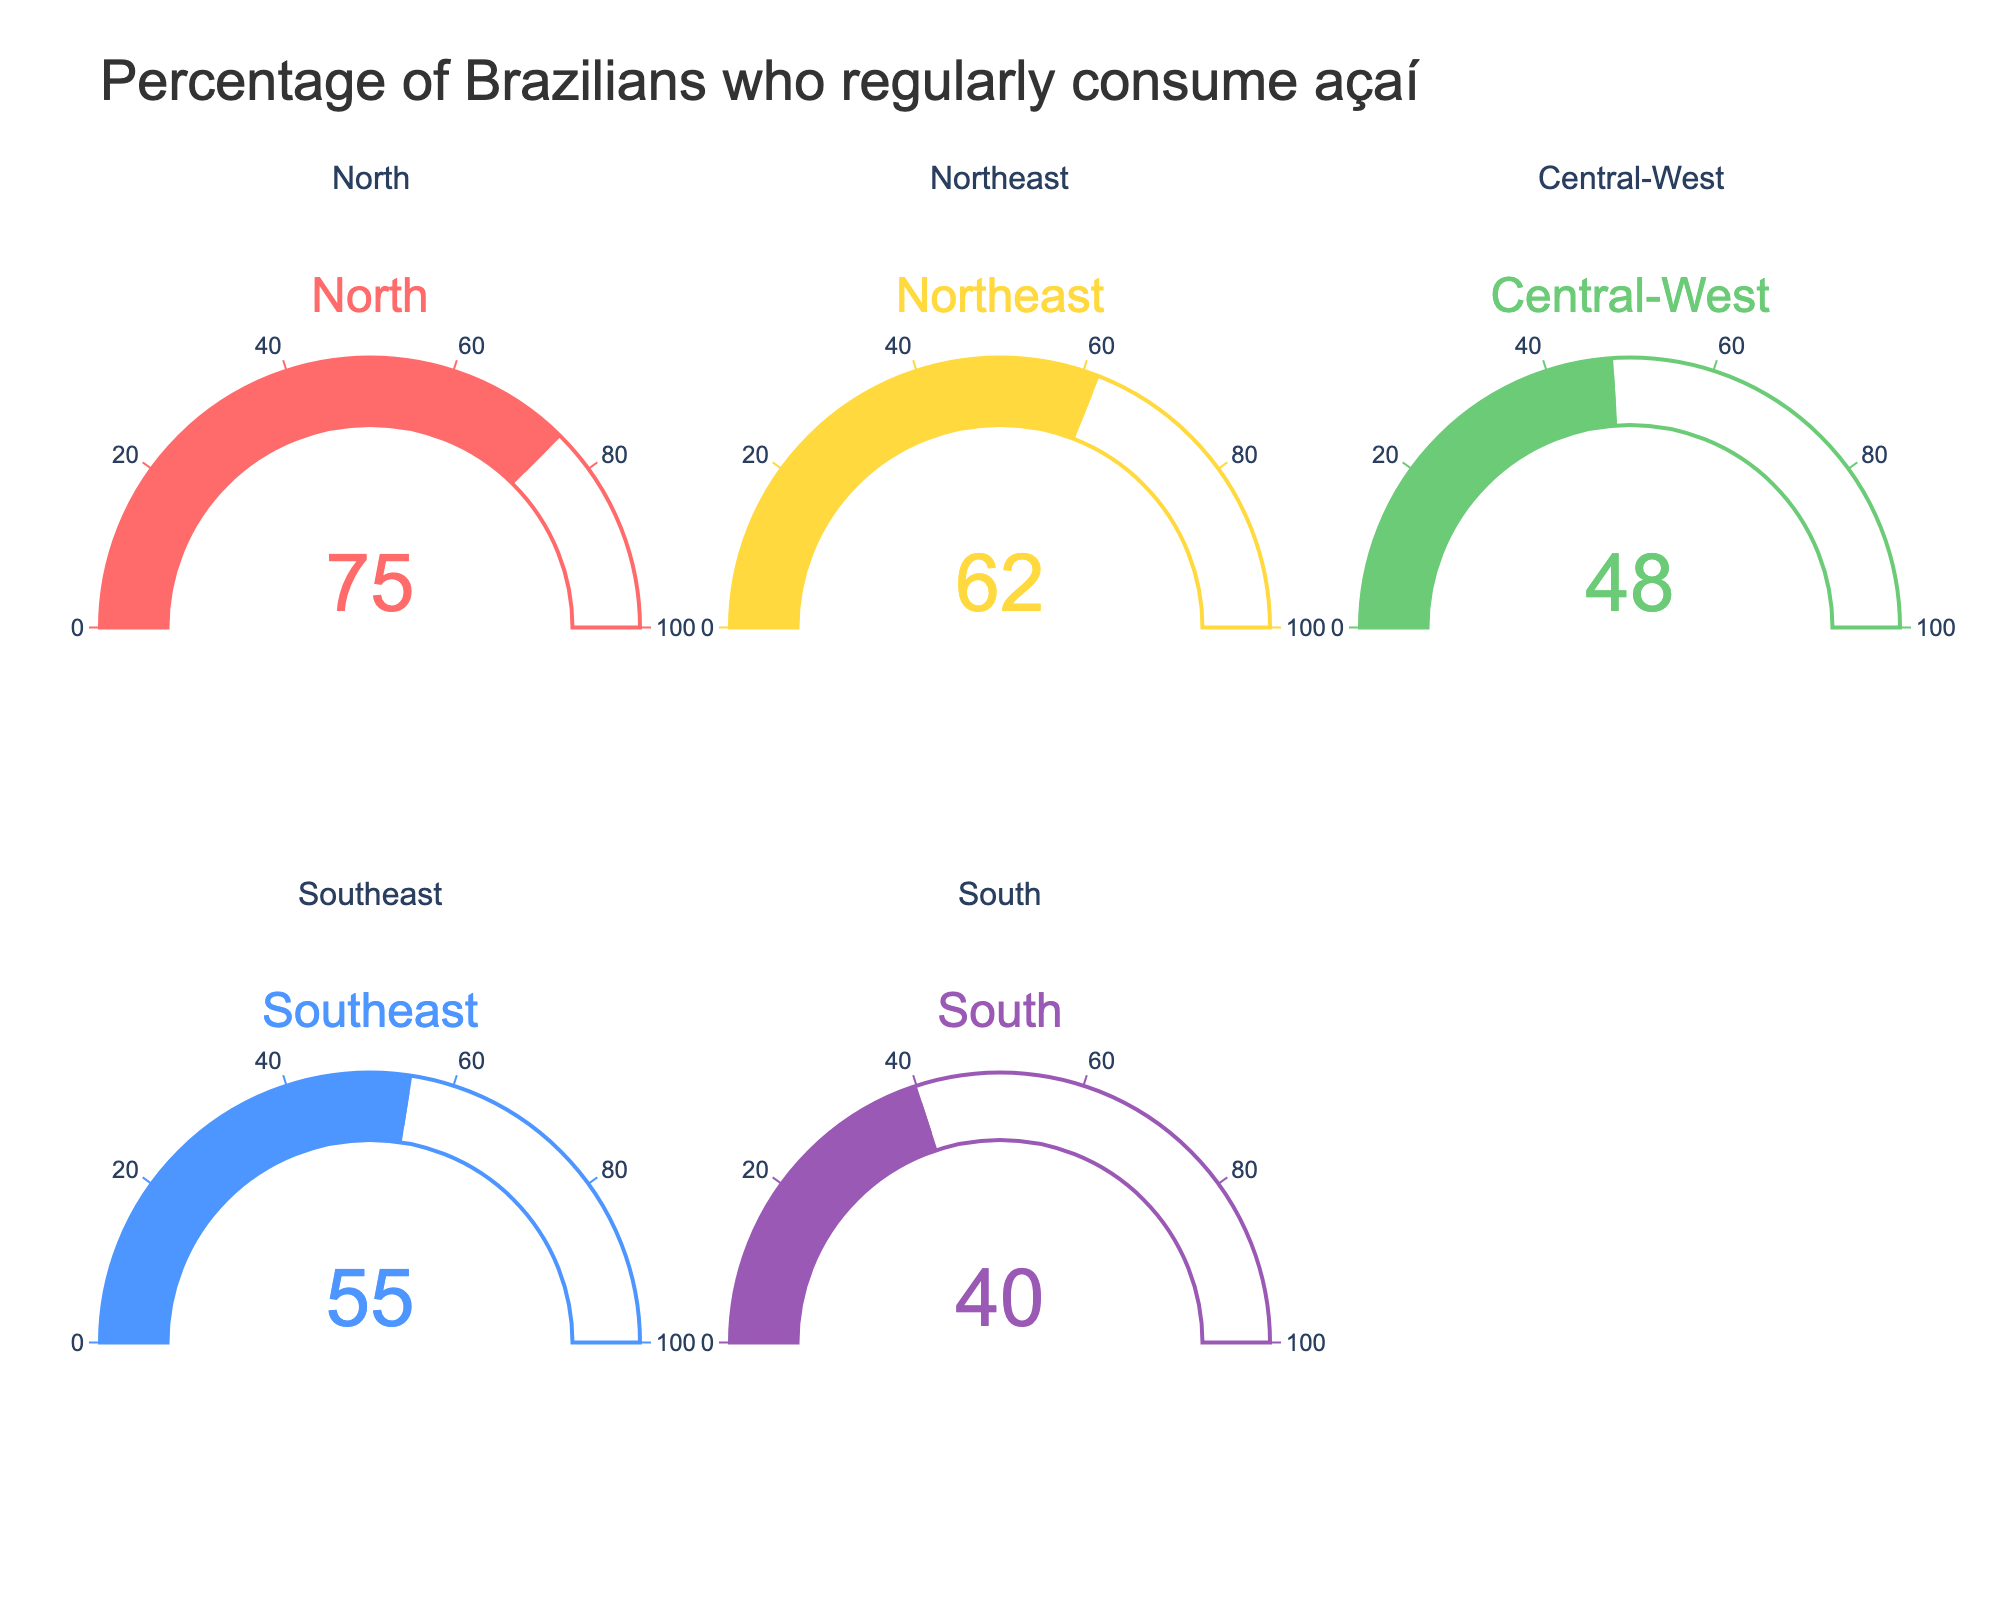Which region has the highest percentage of Brazilians who regularly consume açaí? The North region has a gauge showing 75%, which is the highest among all regions listed.
Answer: North What's the lowest percentage shown on the gauge charts? The South region shows a percentage of 40%, which is the lowest among all listed regions.
Answer: 40 Compare the percentage of Brazilians who consume açaí in the North and Central-West regions. How much higher is it in the North? The North is at 75%, and the Central-West is at 48%. The difference is 75% - 48% = 27%.
Answer: 27% Is the percentage of Brazilians who consume açaí in the Northeast higher or lower than that in the Southeast? The Northeast is at 62%, and the Southeast is at 55%. Hence, the Northeast is higher.
Answer: Higher Calculate the average percentage of all the regions listed. The percentages are 75, 62, 48, 55, and 40. The sum is 75 + 62 + 48 + 55 + 40 = 280. The average is 280/5 = 56%.
Answer: 56% Which region falls closest to the national average percentage of Brazilians who consume açaí? The national average is 56%. The Southeast region, with 55%, is closest to this average.
Answer: Southeast What number is displayed on the gauge chart for the Southeast region? The Southeast region gauge shows the number 55.
Answer: 55 What's the combined percentage of Brazilians who consume açaí in the North and South regions? The North is at 75%, and the South is at 40%. The combined percentage is 75% + 40% = 115%.
Answer: 115% How much more do Brazilians in the Northeast consume açaí compared to the South? The Northeast is at 62%, and the South is at 40%. The difference is 62% - 40% = 22%.
Answer: 22% 